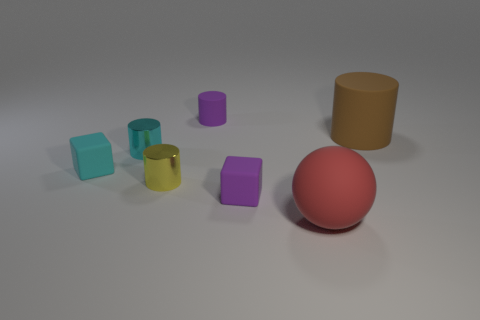Is there any other thing that has the same shape as the red thing?
Your answer should be compact. No. What color is the other small matte object that is the same shape as the tiny yellow thing?
Your response must be concise. Purple. How big is the yellow metallic object?
Offer a terse response. Small. Is the number of cyan cylinders that are to the right of the tiny purple block less than the number of green rubber objects?
Provide a short and direct response. No. Do the tiny purple cylinder and the big cylinder to the right of the tiny purple cube have the same material?
Give a very brief answer. Yes. Is there a purple rubber thing that is behind the thing to the right of the big thing that is to the left of the big brown cylinder?
Provide a succinct answer. Yes. There is another tiny cylinder that is made of the same material as the cyan cylinder; what color is it?
Your answer should be compact. Yellow. There is a matte object that is both on the right side of the tiny rubber cylinder and behind the tiny cyan rubber thing; what size is it?
Provide a short and direct response. Large. Are there fewer matte spheres behind the cyan metal object than big objects that are right of the red matte ball?
Your answer should be very brief. Yes. Are the cylinder on the right side of the large red sphere and the cube that is on the right side of the cyan matte block made of the same material?
Give a very brief answer. Yes. 